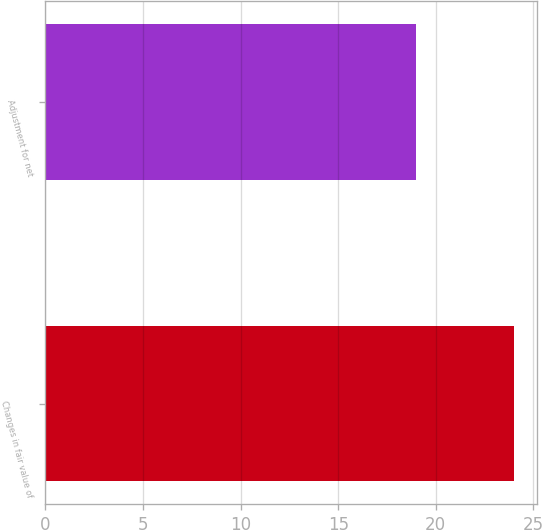Convert chart to OTSL. <chart><loc_0><loc_0><loc_500><loc_500><bar_chart><fcel>Changes in fair value of<fcel>Adjustment for net<nl><fcel>24<fcel>19<nl></chart> 